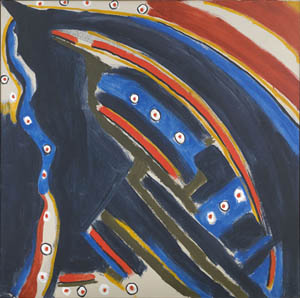Can you describe the main features of this image for me? This image presents a captivating piece of abstract art characterized by its deep blue and black background, which creates a profound and enigmatic atmosphere. The painting is dominantly occupied by an abstract shape outlined in stark white, adding a sharp contrast to the background. This central shape is intricately adorned with dots of red, yellow, and white scattered around like stars in the night sky, contributing to an ethereal quality. The image’s composition and color scheme are reminiscent of the expressionist works by abstract art pioneer Wassily Kandinsky. The bold use of colors, abstract forms, and the overall emotional resonance are indicative of this genre. The piece invites viewers to delve into their own interpretations and explore the unique emotions it invokes. 